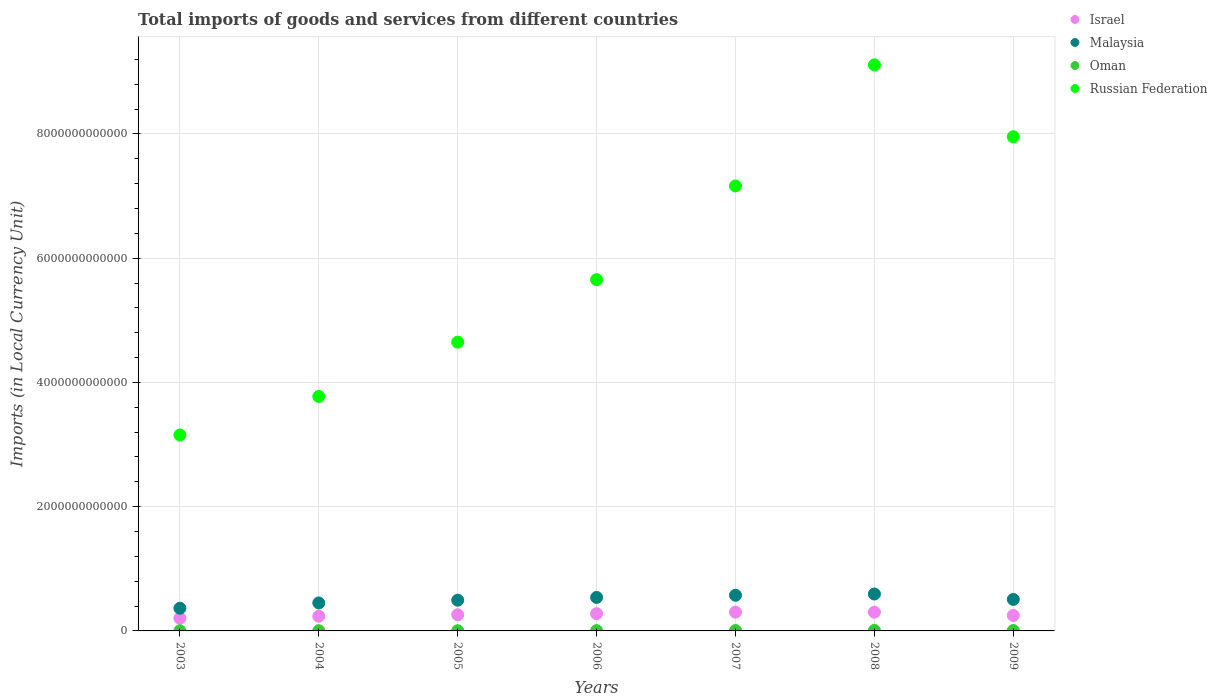How many different coloured dotlines are there?
Provide a short and direct response. 4. What is the Amount of goods and services imports in Oman in 2006?
Ensure brevity in your answer.  4.53e+09. Across all years, what is the maximum Amount of goods and services imports in Malaysia?
Offer a very short reply. 5.94e+11. Across all years, what is the minimum Amount of goods and services imports in Malaysia?
Offer a terse response. 3.65e+11. In which year was the Amount of goods and services imports in Russian Federation minimum?
Ensure brevity in your answer.  2003. What is the total Amount of goods and services imports in Russian Federation in the graph?
Your answer should be compact. 4.15e+13. What is the difference between the Amount of goods and services imports in Malaysia in 2004 and that in 2008?
Your answer should be compact. -1.44e+11. What is the difference between the Amount of goods and services imports in Malaysia in 2004 and the Amount of goods and services imports in Israel in 2007?
Your response must be concise. 1.47e+11. What is the average Amount of goods and services imports in Russian Federation per year?
Provide a succinct answer. 5.92e+12. In the year 2004, what is the difference between the Amount of goods and services imports in Malaysia and Amount of goods and services imports in Russian Federation?
Give a very brief answer. -3.32e+12. What is the ratio of the Amount of goods and services imports in Oman in 2006 to that in 2007?
Provide a short and direct response. 0.7. Is the Amount of goods and services imports in Oman in 2006 less than that in 2009?
Provide a succinct answer. Yes. Is the difference between the Amount of goods and services imports in Malaysia in 2004 and 2005 greater than the difference between the Amount of goods and services imports in Russian Federation in 2004 and 2005?
Your answer should be compact. Yes. What is the difference between the highest and the second highest Amount of goods and services imports in Oman?
Your answer should be compact. 2.24e+09. What is the difference between the highest and the lowest Amount of goods and services imports in Russian Federation?
Offer a terse response. 5.96e+12. Is the sum of the Amount of goods and services imports in Israel in 2004 and 2007 greater than the maximum Amount of goods and services imports in Russian Federation across all years?
Your answer should be very brief. No. Is the Amount of goods and services imports in Russian Federation strictly greater than the Amount of goods and services imports in Oman over the years?
Provide a short and direct response. Yes. Is the Amount of goods and services imports in Malaysia strictly less than the Amount of goods and services imports in Oman over the years?
Offer a terse response. No. How many years are there in the graph?
Your response must be concise. 7. What is the difference between two consecutive major ticks on the Y-axis?
Keep it short and to the point. 2.00e+12. Are the values on the major ticks of Y-axis written in scientific E-notation?
Your answer should be very brief. No. Does the graph contain grids?
Provide a short and direct response. Yes. How are the legend labels stacked?
Offer a terse response. Vertical. What is the title of the graph?
Make the answer very short. Total imports of goods and services from different countries. Does "Latvia" appear as one of the legend labels in the graph?
Offer a very short reply. No. What is the label or title of the X-axis?
Give a very brief answer. Years. What is the label or title of the Y-axis?
Keep it short and to the point. Imports (in Local Currency Unit). What is the Imports (in Local Currency Unit) in Israel in 2003?
Provide a succinct answer. 2.04e+11. What is the Imports (in Local Currency Unit) in Malaysia in 2003?
Offer a very short reply. 3.65e+11. What is the Imports (in Local Currency Unit) of Oman in 2003?
Provide a short and direct response. 2.73e+09. What is the Imports (in Local Currency Unit) of Russian Federation in 2003?
Give a very brief answer. 3.15e+12. What is the Imports (in Local Currency Unit) of Israel in 2004?
Offer a very short reply. 2.36e+11. What is the Imports (in Local Currency Unit) in Malaysia in 2004?
Your answer should be compact. 4.50e+11. What is the Imports (in Local Currency Unit) in Oman in 2004?
Offer a terse response. 3.70e+09. What is the Imports (in Local Currency Unit) in Russian Federation in 2004?
Provide a succinct answer. 3.77e+12. What is the Imports (in Local Currency Unit) of Israel in 2005?
Offer a very short reply. 2.61e+11. What is the Imports (in Local Currency Unit) in Malaysia in 2005?
Offer a terse response. 4.94e+11. What is the Imports (in Local Currency Unit) of Oman in 2005?
Ensure brevity in your answer.  3.71e+09. What is the Imports (in Local Currency Unit) in Russian Federation in 2005?
Keep it short and to the point. 4.65e+12. What is the Imports (in Local Currency Unit) of Israel in 2006?
Provide a short and direct response. 2.78e+11. What is the Imports (in Local Currency Unit) of Malaysia in 2006?
Your response must be concise. 5.39e+11. What is the Imports (in Local Currency Unit) of Oman in 2006?
Offer a very short reply. 4.53e+09. What is the Imports (in Local Currency Unit) in Russian Federation in 2006?
Ensure brevity in your answer.  5.65e+12. What is the Imports (in Local Currency Unit) of Israel in 2007?
Offer a very short reply. 3.03e+11. What is the Imports (in Local Currency Unit) in Malaysia in 2007?
Ensure brevity in your answer.  5.74e+11. What is the Imports (in Local Currency Unit) in Oman in 2007?
Provide a succinct answer. 6.47e+09. What is the Imports (in Local Currency Unit) in Russian Federation in 2007?
Give a very brief answer. 7.16e+12. What is the Imports (in Local Currency Unit) of Israel in 2008?
Ensure brevity in your answer.  3.02e+11. What is the Imports (in Local Currency Unit) in Malaysia in 2008?
Provide a succinct answer. 5.94e+11. What is the Imports (in Local Currency Unit) of Oman in 2008?
Offer a very short reply. 8.71e+09. What is the Imports (in Local Currency Unit) of Russian Federation in 2008?
Your response must be concise. 9.11e+12. What is the Imports (in Local Currency Unit) in Israel in 2009?
Give a very brief answer. 2.49e+11. What is the Imports (in Local Currency Unit) of Malaysia in 2009?
Offer a very short reply. 5.07e+11. What is the Imports (in Local Currency Unit) of Oman in 2009?
Provide a succinct answer. 6.45e+09. What is the Imports (in Local Currency Unit) of Russian Federation in 2009?
Your answer should be very brief. 7.95e+12. Across all years, what is the maximum Imports (in Local Currency Unit) in Israel?
Offer a terse response. 3.03e+11. Across all years, what is the maximum Imports (in Local Currency Unit) in Malaysia?
Ensure brevity in your answer.  5.94e+11. Across all years, what is the maximum Imports (in Local Currency Unit) in Oman?
Ensure brevity in your answer.  8.71e+09. Across all years, what is the maximum Imports (in Local Currency Unit) in Russian Federation?
Make the answer very short. 9.11e+12. Across all years, what is the minimum Imports (in Local Currency Unit) of Israel?
Offer a terse response. 2.04e+11. Across all years, what is the minimum Imports (in Local Currency Unit) of Malaysia?
Keep it short and to the point. 3.65e+11. Across all years, what is the minimum Imports (in Local Currency Unit) of Oman?
Make the answer very short. 2.73e+09. Across all years, what is the minimum Imports (in Local Currency Unit) of Russian Federation?
Your response must be concise. 3.15e+12. What is the total Imports (in Local Currency Unit) of Israel in the graph?
Ensure brevity in your answer.  1.83e+12. What is the total Imports (in Local Currency Unit) in Malaysia in the graph?
Ensure brevity in your answer.  3.53e+12. What is the total Imports (in Local Currency Unit) of Oman in the graph?
Ensure brevity in your answer.  3.63e+1. What is the total Imports (in Local Currency Unit) of Russian Federation in the graph?
Provide a short and direct response. 4.15e+13. What is the difference between the Imports (in Local Currency Unit) of Israel in 2003 and that in 2004?
Ensure brevity in your answer.  -3.24e+1. What is the difference between the Imports (in Local Currency Unit) of Malaysia in 2003 and that in 2004?
Your answer should be very brief. -8.50e+1. What is the difference between the Imports (in Local Currency Unit) of Oman in 2003 and that in 2004?
Offer a terse response. -9.73e+08. What is the difference between the Imports (in Local Currency Unit) of Russian Federation in 2003 and that in 2004?
Ensure brevity in your answer.  -6.20e+11. What is the difference between the Imports (in Local Currency Unit) in Israel in 2003 and that in 2005?
Give a very brief answer. -5.69e+1. What is the difference between the Imports (in Local Currency Unit) of Malaysia in 2003 and that in 2005?
Offer a very short reply. -1.29e+11. What is the difference between the Imports (in Local Currency Unit) in Oman in 2003 and that in 2005?
Your answer should be very brief. -9.84e+08. What is the difference between the Imports (in Local Currency Unit) in Russian Federation in 2003 and that in 2005?
Your answer should be compact. -1.49e+12. What is the difference between the Imports (in Local Currency Unit) of Israel in 2003 and that in 2006?
Give a very brief answer. -7.39e+1. What is the difference between the Imports (in Local Currency Unit) in Malaysia in 2003 and that in 2006?
Keep it short and to the point. -1.74e+11. What is the difference between the Imports (in Local Currency Unit) in Oman in 2003 and that in 2006?
Give a very brief answer. -1.80e+09. What is the difference between the Imports (in Local Currency Unit) of Russian Federation in 2003 and that in 2006?
Ensure brevity in your answer.  -2.50e+12. What is the difference between the Imports (in Local Currency Unit) of Israel in 2003 and that in 2007?
Provide a succinct answer. -9.89e+1. What is the difference between the Imports (in Local Currency Unit) in Malaysia in 2003 and that in 2007?
Ensure brevity in your answer.  -2.09e+11. What is the difference between the Imports (in Local Currency Unit) in Oman in 2003 and that in 2007?
Make the answer very short. -3.74e+09. What is the difference between the Imports (in Local Currency Unit) of Russian Federation in 2003 and that in 2007?
Your response must be concise. -4.01e+12. What is the difference between the Imports (in Local Currency Unit) of Israel in 2003 and that in 2008?
Your answer should be compact. -9.79e+1. What is the difference between the Imports (in Local Currency Unit) in Malaysia in 2003 and that in 2008?
Offer a terse response. -2.29e+11. What is the difference between the Imports (in Local Currency Unit) in Oman in 2003 and that in 2008?
Ensure brevity in your answer.  -5.98e+09. What is the difference between the Imports (in Local Currency Unit) in Russian Federation in 2003 and that in 2008?
Offer a terse response. -5.96e+12. What is the difference between the Imports (in Local Currency Unit) of Israel in 2003 and that in 2009?
Give a very brief answer. -4.50e+1. What is the difference between the Imports (in Local Currency Unit) in Malaysia in 2003 and that in 2009?
Provide a succinct answer. -1.42e+11. What is the difference between the Imports (in Local Currency Unit) in Oman in 2003 and that in 2009?
Make the answer very short. -3.72e+09. What is the difference between the Imports (in Local Currency Unit) of Russian Federation in 2003 and that in 2009?
Provide a short and direct response. -4.80e+12. What is the difference between the Imports (in Local Currency Unit) in Israel in 2004 and that in 2005?
Give a very brief answer. -2.45e+1. What is the difference between the Imports (in Local Currency Unit) of Malaysia in 2004 and that in 2005?
Provide a short and direct response. -4.41e+1. What is the difference between the Imports (in Local Currency Unit) of Oman in 2004 and that in 2005?
Your answer should be very brief. -1.10e+07. What is the difference between the Imports (in Local Currency Unit) of Russian Federation in 2004 and that in 2005?
Make the answer very short. -8.74e+11. What is the difference between the Imports (in Local Currency Unit) of Israel in 2004 and that in 2006?
Ensure brevity in your answer.  -4.15e+1. What is the difference between the Imports (in Local Currency Unit) of Malaysia in 2004 and that in 2006?
Give a very brief answer. -8.91e+1. What is the difference between the Imports (in Local Currency Unit) of Oman in 2004 and that in 2006?
Provide a short and direct response. -8.30e+08. What is the difference between the Imports (in Local Currency Unit) in Russian Federation in 2004 and that in 2006?
Provide a succinct answer. -1.88e+12. What is the difference between the Imports (in Local Currency Unit) in Israel in 2004 and that in 2007?
Keep it short and to the point. -6.65e+1. What is the difference between the Imports (in Local Currency Unit) in Malaysia in 2004 and that in 2007?
Offer a very short reply. -1.24e+11. What is the difference between the Imports (in Local Currency Unit) of Oman in 2004 and that in 2007?
Keep it short and to the point. -2.77e+09. What is the difference between the Imports (in Local Currency Unit) of Russian Federation in 2004 and that in 2007?
Give a very brief answer. -3.39e+12. What is the difference between the Imports (in Local Currency Unit) in Israel in 2004 and that in 2008?
Ensure brevity in your answer.  -6.55e+1. What is the difference between the Imports (in Local Currency Unit) of Malaysia in 2004 and that in 2008?
Keep it short and to the point. -1.44e+11. What is the difference between the Imports (in Local Currency Unit) in Oman in 2004 and that in 2008?
Provide a short and direct response. -5.01e+09. What is the difference between the Imports (in Local Currency Unit) in Russian Federation in 2004 and that in 2008?
Provide a succinct answer. -5.34e+12. What is the difference between the Imports (in Local Currency Unit) in Israel in 2004 and that in 2009?
Your response must be concise. -1.26e+1. What is the difference between the Imports (in Local Currency Unit) of Malaysia in 2004 and that in 2009?
Ensure brevity in your answer.  -5.68e+1. What is the difference between the Imports (in Local Currency Unit) in Oman in 2004 and that in 2009?
Your response must be concise. -2.74e+09. What is the difference between the Imports (in Local Currency Unit) of Russian Federation in 2004 and that in 2009?
Keep it short and to the point. -4.18e+12. What is the difference between the Imports (in Local Currency Unit) in Israel in 2005 and that in 2006?
Your answer should be compact. -1.70e+1. What is the difference between the Imports (in Local Currency Unit) in Malaysia in 2005 and that in 2006?
Make the answer very short. -4.50e+1. What is the difference between the Imports (in Local Currency Unit) in Oman in 2005 and that in 2006?
Make the answer very short. -8.19e+08. What is the difference between the Imports (in Local Currency Unit) of Russian Federation in 2005 and that in 2006?
Provide a short and direct response. -1.01e+12. What is the difference between the Imports (in Local Currency Unit) in Israel in 2005 and that in 2007?
Give a very brief answer. -4.20e+1. What is the difference between the Imports (in Local Currency Unit) of Malaysia in 2005 and that in 2007?
Your answer should be compact. -7.98e+1. What is the difference between the Imports (in Local Currency Unit) of Oman in 2005 and that in 2007?
Ensure brevity in your answer.  -2.76e+09. What is the difference between the Imports (in Local Currency Unit) of Russian Federation in 2005 and that in 2007?
Keep it short and to the point. -2.51e+12. What is the difference between the Imports (in Local Currency Unit) of Israel in 2005 and that in 2008?
Ensure brevity in your answer.  -4.10e+1. What is the difference between the Imports (in Local Currency Unit) in Malaysia in 2005 and that in 2008?
Provide a short and direct response. -9.97e+1. What is the difference between the Imports (in Local Currency Unit) in Oman in 2005 and that in 2008?
Your answer should be compact. -5.00e+09. What is the difference between the Imports (in Local Currency Unit) of Russian Federation in 2005 and that in 2008?
Offer a terse response. -4.46e+12. What is the difference between the Imports (in Local Currency Unit) of Israel in 2005 and that in 2009?
Your answer should be very brief. 1.18e+1. What is the difference between the Imports (in Local Currency Unit) in Malaysia in 2005 and that in 2009?
Provide a short and direct response. -1.27e+1. What is the difference between the Imports (in Local Currency Unit) in Oman in 2005 and that in 2009?
Ensure brevity in your answer.  -2.73e+09. What is the difference between the Imports (in Local Currency Unit) of Russian Federation in 2005 and that in 2009?
Your response must be concise. -3.31e+12. What is the difference between the Imports (in Local Currency Unit) in Israel in 2006 and that in 2007?
Ensure brevity in your answer.  -2.50e+1. What is the difference between the Imports (in Local Currency Unit) in Malaysia in 2006 and that in 2007?
Offer a terse response. -3.47e+1. What is the difference between the Imports (in Local Currency Unit) in Oman in 2006 and that in 2007?
Your response must be concise. -1.94e+09. What is the difference between the Imports (in Local Currency Unit) of Russian Federation in 2006 and that in 2007?
Make the answer very short. -1.51e+12. What is the difference between the Imports (in Local Currency Unit) of Israel in 2006 and that in 2008?
Provide a succinct answer. -2.40e+1. What is the difference between the Imports (in Local Currency Unit) in Malaysia in 2006 and that in 2008?
Your answer should be compact. -5.47e+1. What is the difference between the Imports (in Local Currency Unit) in Oman in 2006 and that in 2008?
Offer a terse response. -4.18e+09. What is the difference between the Imports (in Local Currency Unit) in Russian Federation in 2006 and that in 2008?
Provide a short and direct response. -3.46e+12. What is the difference between the Imports (in Local Currency Unit) in Israel in 2006 and that in 2009?
Keep it short and to the point. 2.88e+1. What is the difference between the Imports (in Local Currency Unit) of Malaysia in 2006 and that in 2009?
Provide a succinct answer. 3.23e+1. What is the difference between the Imports (in Local Currency Unit) in Oman in 2006 and that in 2009?
Your answer should be very brief. -1.92e+09. What is the difference between the Imports (in Local Currency Unit) in Russian Federation in 2006 and that in 2009?
Your answer should be compact. -2.30e+12. What is the difference between the Imports (in Local Currency Unit) in Israel in 2007 and that in 2008?
Offer a very short reply. 1.01e+09. What is the difference between the Imports (in Local Currency Unit) of Malaysia in 2007 and that in 2008?
Provide a short and direct response. -2.00e+1. What is the difference between the Imports (in Local Currency Unit) in Oman in 2007 and that in 2008?
Your answer should be very brief. -2.24e+09. What is the difference between the Imports (in Local Currency Unit) of Russian Federation in 2007 and that in 2008?
Offer a very short reply. -1.95e+12. What is the difference between the Imports (in Local Currency Unit) in Israel in 2007 and that in 2009?
Provide a short and direct response. 5.39e+1. What is the difference between the Imports (in Local Currency Unit) of Malaysia in 2007 and that in 2009?
Your response must be concise. 6.70e+1. What is the difference between the Imports (in Local Currency Unit) in Oman in 2007 and that in 2009?
Offer a very short reply. 2.50e+07. What is the difference between the Imports (in Local Currency Unit) in Russian Federation in 2007 and that in 2009?
Your answer should be compact. -7.92e+11. What is the difference between the Imports (in Local Currency Unit) in Israel in 2008 and that in 2009?
Provide a succinct answer. 5.28e+1. What is the difference between the Imports (in Local Currency Unit) in Malaysia in 2008 and that in 2009?
Make the answer very short. 8.70e+1. What is the difference between the Imports (in Local Currency Unit) of Oman in 2008 and that in 2009?
Your response must be concise. 2.26e+09. What is the difference between the Imports (in Local Currency Unit) in Russian Federation in 2008 and that in 2009?
Provide a short and direct response. 1.16e+12. What is the difference between the Imports (in Local Currency Unit) in Israel in 2003 and the Imports (in Local Currency Unit) in Malaysia in 2004?
Give a very brief answer. -2.46e+11. What is the difference between the Imports (in Local Currency Unit) of Israel in 2003 and the Imports (in Local Currency Unit) of Oman in 2004?
Your response must be concise. 2.00e+11. What is the difference between the Imports (in Local Currency Unit) of Israel in 2003 and the Imports (in Local Currency Unit) of Russian Federation in 2004?
Your answer should be compact. -3.57e+12. What is the difference between the Imports (in Local Currency Unit) in Malaysia in 2003 and the Imports (in Local Currency Unit) in Oman in 2004?
Provide a short and direct response. 3.62e+11. What is the difference between the Imports (in Local Currency Unit) in Malaysia in 2003 and the Imports (in Local Currency Unit) in Russian Federation in 2004?
Keep it short and to the point. -3.41e+12. What is the difference between the Imports (in Local Currency Unit) in Oman in 2003 and the Imports (in Local Currency Unit) in Russian Federation in 2004?
Make the answer very short. -3.77e+12. What is the difference between the Imports (in Local Currency Unit) in Israel in 2003 and the Imports (in Local Currency Unit) in Malaysia in 2005?
Offer a terse response. -2.90e+11. What is the difference between the Imports (in Local Currency Unit) in Israel in 2003 and the Imports (in Local Currency Unit) in Oman in 2005?
Provide a short and direct response. 2.00e+11. What is the difference between the Imports (in Local Currency Unit) of Israel in 2003 and the Imports (in Local Currency Unit) of Russian Federation in 2005?
Offer a very short reply. -4.44e+12. What is the difference between the Imports (in Local Currency Unit) of Malaysia in 2003 and the Imports (in Local Currency Unit) of Oman in 2005?
Make the answer very short. 3.62e+11. What is the difference between the Imports (in Local Currency Unit) of Malaysia in 2003 and the Imports (in Local Currency Unit) of Russian Federation in 2005?
Your answer should be very brief. -4.28e+12. What is the difference between the Imports (in Local Currency Unit) of Oman in 2003 and the Imports (in Local Currency Unit) of Russian Federation in 2005?
Ensure brevity in your answer.  -4.65e+12. What is the difference between the Imports (in Local Currency Unit) of Israel in 2003 and the Imports (in Local Currency Unit) of Malaysia in 2006?
Provide a short and direct response. -3.35e+11. What is the difference between the Imports (in Local Currency Unit) in Israel in 2003 and the Imports (in Local Currency Unit) in Oman in 2006?
Your answer should be compact. 2.00e+11. What is the difference between the Imports (in Local Currency Unit) of Israel in 2003 and the Imports (in Local Currency Unit) of Russian Federation in 2006?
Keep it short and to the point. -5.45e+12. What is the difference between the Imports (in Local Currency Unit) of Malaysia in 2003 and the Imports (in Local Currency Unit) of Oman in 2006?
Keep it short and to the point. 3.61e+11. What is the difference between the Imports (in Local Currency Unit) of Malaysia in 2003 and the Imports (in Local Currency Unit) of Russian Federation in 2006?
Provide a succinct answer. -5.29e+12. What is the difference between the Imports (in Local Currency Unit) of Oman in 2003 and the Imports (in Local Currency Unit) of Russian Federation in 2006?
Give a very brief answer. -5.65e+12. What is the difference between the Imports (in Local Currency Unit) in Israel in 2003 and the Imports (in Local Currency Unit) in Malaysia in 2007?
Your response must be concise. -3.70e+11. What is the difference between the Imports (in Local Currency Unit) of Israel in 2003 and the Imports (in Local Currency Unit) of Oman in 2007?
Provide a succinct answer. 1.98e+11. What is the difference between the Imports (in Local Currency Unit) in Israel in 2003 and the Imports (in Local Currency Unit) in Russian Federation in 2007?
Ensure brevity in your answer.  -6.96e+12. What is the difference between the Imports (in Local Currency Unit) of Malaysia in 2003 and the Imports (in Local Currency Unit) of Oman in 2007?
Provide a succinct answer. 3.59e+11. What is the difference between the Imports (in Local Currency Unit) of Malaysia in 2003 and the Imports (in Local Currency Unit) of Russian Federation in 2007?
Your answer should be compact. -6.80e+12. What is the difference between the Imports (in Local Currency Unit) in Oman in 2003 and the Imports (in Local Currency Unit) in Russian Federation in 2007?
Keep it short and to the point. -7.16e+12. What is the difference between the Imports (in Local Currency Unit) in Israel in 2003 and the Imports (in Local Currency Unit) in Malaysia in 2008?
Your response must be concise. -3.90e+11. What is the difference between the Imports (in Local Currency Unit) in Israel in 2003 and the Imports (in Local Currency Unit) in Oman in 2008?
Your answer should be very brief. 1.95e+11. What is the difference between the Imports (in Local Currency Unit) in Israel in 2003 and the Imports (in Local Currency Unit) in Russian Federation in 2008?
Ensure brevity in your answer.  -8.91e+12. What is the difference between the Imports (in Local Currency Unit) of Malaysia in 2003 and the Imports (in Local Currency Unit) of Oman in 2008?
Keep it short and to the point. 3.57e+11. What is the difference between the Imports (in Local Currency Unit) in Malaysia in 2003 and the Imports (in Local Currency Unit) in Russian Federation in 2008?
Your answer should be compact. -8.75e+12. What is the difference between the Imports (in Local Currency Unit) of Oman in 2003 and the Imports (in Local Currency Unit) of Russian Federation in 2008?
Your response must be concise. -9.11e+12. What is the difference between the Imports (in Local Currency Unit) in Israel in 2003 and the Imports (in Local Currency Unit) in Malaysia in 2009?
Make the answer very short. -3.03e+11. What is the difference between the Imports (in Local Currency Unit) in Israel in 2003 and the Imports (in Local Currency Unit) in Oman in 2009?
Offer a terse response. 1.98e+11. What is the difference between the Imports (in Local Currency Unit) in Israel in 2003 and the Imports (in Local Currency Unit) in Russian Federation in 2009?
Keep it short and to the point. -7.75e+12. What is the difference between the Imports (in Local Currency Unit) of Malaysia in 2003 and the Imports (in Local Currency Unit) of Oman in 2009?
Your answer should be very brief. 3.59e+11. What is the difference between the Imports (in Local Currency Unit) in Malaysia in 2003 and the Imports (in Local Currency Unit) in Russian Federation in 2009?
Provide a short and direct response. -7.59e+12. What is the difference between the Imports (in Local Currency Unit) in Oman in 2003 and the Imports (in Local Currency Unit) in Russian Federation in 2009?
Offer a very short reply. -7.95e+12. What is the difference between the Imports (in Local Currency Unit) in Israel in 2004 and the Imports (in Local Currency Unit) in Malaysia in 2005?
Your answer should be compact. -2.58e+11. What is the difference between the Imports (in Local Currency Unit) of Israel in 2004 and the Imports (in Local Currency Unit) of Oman in 2005?
Your answer should be very brief. 2.33e+11. What is the difference between the Imports (in Local Currency Unit) of Israel in 2004 and the Imports (in Local Currency Unit) of Russian Federation in 2005?
Your answer should be very brief. -4.41e+12. What is the difference between the Imports (in Local Currency Unit) of Malaysia in 2004 and the Imports (in Local Currency Unit) of Oman in 2005?
Offer a terse response. 4.47e+11. What is the difference between the Imports (in Local Currency Unit) in Malaysia in 2004 and the Imports (in Local Currency Unit) in Russian Federation in 2005?
Your response must be concise. -4.20e+12. What is the difference between the Imports (in Local Currency Unit) in Oman in 2004 and the Imports (in Local Currency Unit) in Russian Federation in 2005?
Your answer should be very brief. -4.64e+12. What is the difference between the Imports (in Local Currency Unit) in Israel in 2004 and the Imports (in Local Currency Unit) in Malaysia in 2006?
Offer a terse response. -3.03e+11. What is the difference between the Imports (in Local Currency Unit) in Israel in 2004 and the Imports (in Local Currency Unit) in Oman in 2006?
Offer a terse response. 2.32e+11. What is the difference between the Imports (in Local Currency Unit) in Israel in 2004 and the Imports (in Local Currency Unit) in Russian Federation in 2006?
Give a very brief answer. -5.42e+12. What is the difference between the Imports (in Local Currency Unit) of Malaysia in 2004 and the Imports (in Local Currency Unit) of Oman in 2006?
Keep it short and to the point. 4.46e+11. What is the difference between the Imports (in Local Currency Unit) of Malaysia in 2004 and the Imports (in Local Currency Unit) of Russian Federation in 2006?
Provide a short and direct response. -5.20e+12. What is the difference between the Imports (in Local Currency Unit) in Oman in 2004 and the Imports (in Local Currency Unit) in Russian Federation in 2006?
Make the answer very short. -5.65e+12. What is the difference between the Imports (in Local Currency Unit) in Israel in 2004 and the Imports (in Local Currency Unit) in Malaysia in 2007?
Your answer should be very brief. -3.38e+11. What is the difference between the Imports (in Local Currency Unit) in Israel in 2004 and the Imports (in Local Currency Unit) in Oman in 2007?
Offer a terse response. 2.30e+11. What is the difference between the Imports (in Local Currency Unit) in Israel in 2004 and the Imports (in Local Currency Unit) in Russian Federation in 2007?
Provide a short and direct response. -6.93e+12. What is the difference between the Imports (in Local Currency Unit) in Malaysia in 2004 and the Imports (in Local Currency Unit) in Oman in 2007?
Your answer should be very brief. 4.44e+11. What is the difference between the Imports (in Local Currency Unit) of Malaysia in 2004 and the Imports (in Local Currency Unit) of Russian Federation in 2007?
Your response must be concise. -6.71e+12. What is the difference between the Imports (in Local Currency Unit) in Oman in 2004 and the Imports (in Local Currency Unit) in Russian Federation in 2007?
Your answer should be very brief. -7.16e+12. What is the difference between the Imports (in Local Currency Unit) of Israel in 2004 and the Imports (in Local Currency Unit) of Malaysia in 2008?
Your answer should be very brief. -3.58e+11. What is the difference between the Imports (in Local Currency Unit) of Israel in 2004 and the Imports (in Local Currency Unit) of Oman in 2008?
Make the answer very short. 2.28e+11. What is the difference between the Imports (in Local Currency Unit) in Israel in 2004 and the Imports (in Local Currency Unit) in Russian Federation in 2008?
Provide a short and direct response. -8.87e+12. What is the difference between the Imports (in Local Currency Unit) of Malaysia in 2004 and the Imports (in Local Currency Unit) of Oman in 2008?
Offer a terse response. 4.42e+11. What is the difference between the Imports (in Local Currency Unit) in Malaysia in 2004 and the Imports (in Local Currency Unit) in Russian Federation in 2008?
Offer a terse response. -8.66e+12. What is the difference between the Imports (in Local Currency Unit) of Oman in 2004 and the Imports (in Local Currency Unit) of Russian Federation in 2008?
Make the answer very short. -9.11e+12. What is the difference between the Imports (in Local Currency Unit) in Israel in 2004 and the Imports (in Local Currency Unit) in Malaysia in 2009?
Your response must be concise. -2.71e+11. What is the difference between the Imports (in Local Currency Unit) of Israel in 2004 and the Imports (in Local Currency Unit) of Oman in 2009?
Give a very brief answer. 2.30e+11. What is the difference between the Imports (in Local Currency Unit) of Israel in 2004 and the Imports (in Local Currency Unit) of Russian Federation in 2009?
Your response must be concise. -7.72e+12. What is the difference between the Imports (in Local Currency Unit) in Malaysia in 2004 and the Imports (in Local Currency Unit) in Oman in 2009?
Provide a succinct answer. 4.44e+11. What is the difference between the Imports (in Local Currency Unit) in Malaysia in 2004 and the Imports (in Local Currency Unit) in Russian Federation in 2009?
Provide a succinct answer. -7.50e+12. What is the difference between the Imports (in Local Currency Unit) in Oman in 2004 and the Imports (in Local Currency Unit) in Russian Federation in 2009?
Give a very brief answer. -7.95e+12. What is the difference between the Imports (in Local Currency Unit) of Israel in 2005 and the Imports (in Local Currency Unit) of Malaysia in 2006?
Keep it short and to the point. -2.79e+11. What is the difference between the Imports (in Local Currency Unit) of Israel in 2005 and the Imports (in Local Currency Unit) of Oman in 2006?
Give a very brief answer. 2.56e+11. What is the difference between the Imports (in Local Currency Unit) in Israel in 2005 and the Imports (in Local Currency Unit) in Russian Federation in 2006?
Give a very brief answer. -5.39e+12. What is the difference between the Imports (in Local Currency Unit) of Malaysia in 2005 and the Imports (in Local Currency Unit) of Oman in 2006?
Provide a succinct answer. 4.90e+11. What is the difference between the Imports (in Local Currency Unit) of Malaysia in 2005 and the Imports (in Local Currency Unit) of Russian Federation in 2006?
Give a very brief answer. -5.16e+12. What is the difference between the Imports (in Local Currency Unit) in Oman in 2005 and the Imports (in Local Currency Unit) in Russian Federation in 2006?
Provide a succinct answer. -5.65e+12. What is the difference between the Imports (in Local Currency Unit) of Israel in 2005 and the Imports (in Local Currency Unit) of Malaysia in 2007?
Make the answer very short. -3.13e+11. What is the difference between the Imports (in Local Currency Unit) of Israel in 2005 and the Imports (in Local Currency Unit) of Oman in 2007?
Your answer should be compact. 2.54e+11. What is the difference between the Imports (in Local Currency Unit) in Israel in 2005 and the Imports (in Local Currency Unit) in Russian Federation in 2007?
Your answer should be very brief. -6.90e+12. What is the difference between the Imports (in Local Currency Unit) in Malaysia in 2005 and the Imports (in Local Currency Unit) in Oman in 2007?
Provide a succinct answer. 4.88e+11. What is the difference between the Imports (in Local Currency Unit) of Malaysia in 2005 and the Imports (in Local Currency Unit) of Russian Federation in 2007?
Your answer should be compact. -6.67e+12. What is the difference between the Imports (in Local Currency Unit) in Oman in 2005 and the Imports (in Local Currency Unit) in Russian Federation in 2007?
Your answer should be very brief. -7.16e+12. What is the difference between the Imports (in Local Currency Unit) of Israel in 2005 and the Imports (in Local Currency Unit) of Malaysia in 2008?
Ensure brevity in your answer.  -3.33e+11. What is the difference between the Imports (in Local Currency Unit) in Israel in 2005 and the Imports (in Local Currency Unit) in Oman in 2008?
Provide a succinct answer. 2.52e+11. What is the difference between the Imports (in Local Currency Unit) in Israel in 2005 and the Imports (in Local Currency Unit) in Russian Federation in 2008?
Give a very brief answer. -8.85e+12. What is the difference between the Imports (in Local Currency Unit) of Malaysia in 2005 and the Imports (in Local Currency Unit) of Oman in 2008?
Offer a terse response. 4.86e+11. What is the difference between the Imports (in Local Currency Unit) in Malaysia in 2005 and the Imports (in Local Currency Unit) in Russian Federation in 2008?
Provide a succinct answer. -8.62e+12. What is the difference between the Imports (in Local Currency Unit) in Oman in 2005 and the Imports (in Local Currency Unit) in Russian Federation in 2008?
Ensure brevity in your answer.  -9.11e+12. What is the difference between the Imports (in Local Currency Unit) of Israel in 2005 and the Imports (in Local Currency Unit) of Malaysia in 2009?
Offer a terse response. -2.46e+11. What is the difference between the Imports (in Local Currency Unit) in Israel in 2005 and the Imports (in Local Currency Unit) in Oman in 2009?
Provide a short and direct response. 2.54e+11. What is the difference between the Imports (in Local Currency Unit) of Israel in 2005 and the Imports (in Local Currency Unit) of Russian Federation in 2009?
Offer a terse response. -7.69e+12. What is the difference between the Imports (in Local Currency Unit) of Malaysia in 2005 and the Imports (in Local Currency Unit) of Oman in 2009?
Offer a terse response. 4.88e+11. What is the difference between the Imports (in Local Currency Unit) in Malaysia in 2005 and the Imports (in Local Currency Unit) in Russian Federation in 2009?
Offer a very short reply. -7.46e+12. What is the difference between the Imports (in Local Currency Unit) of Oman in 2005 and the Imports (in Local Currency Unit) of Russian Federation in 2009?
Your response must be concise. -7.95e+12. What is the difference between the Imports (in Local Currency Unit) in Israel in 2006 and the Imports (in Local Currency Unit) in Malaysia in 2007?
Ensure brevity in your answer.  -2.96e+11. What is the difference between the Imports (in Local Currency Unit) in Israel in 2006 and the Imports (in Local Currency Unit) in Oman in 2007?
Give a very brief answer. 2.71e+11. What is the difference between the Imports (in Local Currency Unit) of Israel in 2006 and the Imports (in Local Currency Unit) of Russian Federation in 2007?
Provide a short and direct response. -6.88e+12. What is the difference between the Imports (in Local Currency Unit) in Malaysia in 2006 and the Imports (in Local Currency Unit) in Oman in 2007?
Keep it short and to the point. 5.33e+11. What is the difference between the Imports (in Local Currency Unit) in Malaysia in 2006 and the Imports (in Local Currency Unit) in Russian Federation in 2007?
Give a very brief answer. -6.62e+12. What is the difference between the Imports (in Local Currency Unit) in Oman in 2006 and the Imports (in Local Currency Unit) in Russian Federation in 2007?
Keep it short and to the point. -7.16e+12. What is the difference between the Imports (in Local Currency Unit) of Israel in 2006 and the Imports (in Local Currency Unit) of Malaysia in 2008?
Provide a short and direct response. -3.16e+11. What is the difference between the Imports (in Local Currency Unit) of Israel in 2006 and the Imports (in Local Currency Unit) of Oman in 2008?
Offer a terse response. 2.69e+11. What is the difference between the Imports (in Local Currency Unit) of Israel in 2006 and the Imports (in Local Currency Unit) of Russian Federation in 2008?
Your answer should be very brief. -8.83e+12. What is the difference between the Imports (in Local Currency Unit) in Malaysia in 2006 and the Imports (in Local Currency Unit) in Oman in 2008?
Your response must be concise. 5.31e+11. What is the difference between the Imports (in Local Currency Unit) in Malaysia in 2006 and the Imports (in Local Currency Unit) in Russian Federation in 2008?
Ensure brevity in your answer.  -8.57e+12. What is the difference between the Imports (in Local Currency Unit) of Oman in 2006 and the Imports (in Local Currency Unit) of Russian Federation in 2008?
Your answer should be very brief. -9.11e+12. What is the difference between the Imports (in Local Currency Unit) in Israel in 2006 and the Imports (in Local Currency Unit) in Malaysia in 2009?
Provide a short and direct response. -2.29e+11. What is the difference between the Imports (in Local Currency Unit) in Israel in 2006 and the Imports (in Local Currency Unit) in Oman in 2009?
Your answer should be compact. 2.71e+11. What is the difference between the Imports (in Local Currency Unit) in Israel in 2006 and the Imports (in Local Currency Unit) in Russian Federation in 2009?
Make the answer very short. -7.68e+12. What is the difference between the Imports (in Local Currency Unit) of Malaysia in 2006 and the Imports (in Local Currency Unit) of Oman in 2009?
Offer a terse response. 5.33e+11. What is the difference between the Imports (in Local Currency Unit) of Malaysia in 2006 and the Imports (in Local Currency Unit) of Russian Federation in 2009?
Offer a very short reply. -7.41e+12. What is the difference between the Imports (in Local Currency Unit) of Oman in 2006 and the Imports (in Local Currency Unit) of Russian Federation in 2009?
Offer a very short reply. -7.95e+12. What is the difference between the Imports (in Local Currency Unit) in Israel in 2007 and the Imports (in Local Currency Unit) in Malaysia in 2008?
Your answer should be very brief. -2.91e+11. What is the difference between the Imports (in Local Currency Unit) in Israel in 2007 and the Imports (in Local Currency Unit) in Oman in 2008?
Provide a short and direct response. 2.94e+11. What is the difference between the Imports (in Local Currency Unit) in Israel in 2007 and the Imports (in Local Currency Unit) in Russian Federation in 2008?
Ensure brevity in your answer.  -8.81e+12. What is the difference between the Imports (in Local Currency Unit) in Malaysia in 2007 and the Imports (in Local Currency Unit) in Oman in 2008?
Provide a succinct answer. 5.65e+11. What is the difference between the Imports (in Local Currency Unit) of Malaysia in 2007 and the Imports (in Local Currency Unit) of Russian Federation in 2008?
Make the answer very short. -8.54e+12. What is the difference between the Imports (in Local Currency Unit) in Oman in 2007 and the Imports (in Local Currency Unit) in Russian Federation in 2008?
Your answer should be compact. -9.10e+12. What is the difference between the Imports (in Local Currency Unit) in Israel in 2007 and the Imports (in Local Currency Unit) in Malaysia in 2009?
Offer a terse response. -2.04e+11. What is the difference between the Imports (in Local Currency Unit) in Israel in 2007 and the Imports (in Local Currency Unit) in Oman in 2009?
Keep it short and to the point. 2.97e+11. What is the difference between the Imports (in Local Currency Unit) in Israel in 2007 and the Imports (in Local Currency Unit) in Russian Federation in 2009?
Offer a very short reply. -7.65e+12. What is the difference between the Imports (in Local Currency Unit) of Malaysia in 2007 and the Imports (in Local Currency Unit) of Oman in 2009?
Your answer should be very brief. 5.68e+11. What is the difference between the Imports (in Local Currency Unit) of Malaysia in 2007 and the Imports (in Local Currency Unit) of Russian Federation in 2009?
Offer a very short reply. -7.38e+12. What is the difference between the Imports (in Local Currency Unit) of Oman in 2007 and the Imports (in Local Currency Unit) of Russian Federation in 2009?
Ensure brevity in your answer.  -7.95e+12. What is the difference between the Imports (in Local Currency Unit) in Israel in 2008 and the Imports (in Local Currency Unit) in Malaysia in 2009?
Keep it short and to the point. -2.05e+11. What is the difference between the Imports (in Local Currency Unit) of Israel in 2008 and the Imports (in Local Currency Unit) of Oman in 2009?
Keep it short and to the point. 2.96e+11. What is the difference between the Imports (in Local Currency Unit) of Israel in 2008 and the Imports (in Local Currency Unit) of Russian Federation in 2009?
Offer a terse response. -7.65e+12. What is the difference between the Imports (in Local Currency Unit) in Malaysia in 2008 and the Imports (in Local Currency Unit) in Oman in 2009?
Offer a very short reply. 5.88e+11. What is the difference between the Imports (in Local Currency Unit) of Malaysia in 2008 and the Imports (in Local Currency Unit) of Russian Federation in 2009?
Ensure brevity in your answer.  -7.36e+12. What is the difference between the Imports (in Local Currency Unit) of Oman in 2008 and the Imports (in Local Currency Unit) of Russian Federation in 2009?
Offer a terse response. -7.95e+12. What is the average Imports (in Local Currency Unit) in Israel per year?
Give a very brief answer. 2.62e+11. What is the average Imports (in Local Currency Unit) in Malaysia per year?
Keep it short and to the point. 5.04e+11. What is the average Imports (in Local Currency Unit) of Oman per year?
Your answer should be compact. 5.19e+09. What is the average Imports (in Local Currency Unit) of Russian Federation per year?
Your answer should be very brief. 5.92e+12. In the year 2003, what is the difference between the Imports (in Local Currency Unit) in Israel and Imports (in Local Currency Unit) in Malaysia?
Offer a terse response. -1.61e+11. In the year 2003, what is the difference between the Imports (in Local Currency Unit) in Israel and Imports (in Local Currency Unit) in Oman?
Offer a terse response. 2.01e+11. In the year 2003, what is the difference between the Imports (in Local Currency Unit) in Israel and Imports (in Local Currency Unit) in Russian Federation?
Offer a very short reply. -2.95e+12. In the year 2003, what is the difference between the Imports (in Local Currency Unit) of Malaysia and Imports (in Local Currency Unit) of Oman?
Your response must be concise. 3.63e+11. In the year 2003, what is the difference between the Imports (in Local Currency Unit) in Malaysia and Imports (in Local Currency Unit) in Russian Federation?
Provide a short and direct response. -2.79e+12. In the year 2003, what is the difference between the Imports (in Local Currency Unit) in Oman and Imports (in Local Currency Unit) in Russian Federation?
Offer a terse response. -3.15e+12. In the year 2004, what is the difference between the Imports (in Local Currency Unit) in Israel and Imports (in Local Currency Unit) in Malaysia?
Provide a succinct answer. -2.14e+11. In the year 2004, what is the difference between the Imports (in Local Currency Unit) in Israel and Imports (in Local Currency Unit) in Oman?
Your answer should be compact. 2.33e+11. In the year 2004, what is the difference between the Imports (in Local Currency Unit) in Israel and Imports (in Local Currency Unit) in Russian Federation?
Give a very brief answer. -3.54e+12. In the year 2004, what is the difference between the Imports (in Local Currency Unit) in Malaysia and Imports (in Local Currency Unit) in Oman?
Provide a short and direct response. 4.47e+11. In the year 2004, what is the difference between the Imports (in Local Currency Unit) in Malaysia and Imports (in Local Currency Unit) in Russian Federation?
Offer a very short reply. -3.32e+12. In the year 2004, what is the difference between the Imports (in Local Currency Unit) of Oman and Imports (in Local Currency Unit) of Russian Federation?
Provide a succinct answer. -3.77e+12. In the year 2005, what is the difference between the Imports (in Local Currency Unit) of Israel and Imports (in Local Currency Unit) of Malaysia?
Keep it short and to the point. -2.33e+11. In the year 2005, what is the difference between the Imports (in Local Currency Unit) of Israel and Imports (in Local Currency Unit) of Oman?
Provide a succinct answer. 2.57e+11. In the year 2005, what is the difference between the Imports (in Local Currency Unit) in Israel and Imports (in Local Currency Unit) in Russian Federation?
Make the answer very short. -4.39e+12. In the year 2005, what is the difference between the Imports (in Local Currency Unit) in Malaysia and Imports (in Local Currency Unit) in Oman?
Your answer should be compact. 4.91e+11. In the year 2005, what is the difference between the Imports (in Local Currency Unit) of Malaysia and Imports (in Local Currency Unit) of Russian Federation?
Provide a succinct answer. -4.15e+12. In the year 2005, what is the difference between the Imports (in Local Currency Unit) of Oman and Imports (in Local Currency Unit) of Russian Federation?
Provide a short and direct response. -4.64e+12. In the year 2006, what is the difference between the Imports (in Local Currency Unit) in Israel and Imports (in Local Currency Unit) in Malaysia?
Offer a terse response. -2.62e+11. In the year 2006, what is the difference between the Imports (in Local Currency Unit) of Israel and Imports (in Local Currency Unit) of Oman?
Give a very brief answer. 2.73e+11. In the year 2006, what is the difference between the Imports (in Local Currency Unit) in Israel and Imports (in Local Currency Unit) in Russian Federation?
Give a very brief answer. -5.38e+12. In the year 2006, what is the difference between the Imports (in Local Currency Unit) in Malaysia and Imports (in Local Currency Unit) in Oman?
Make the answer very short. 5.35e+11. In the year 2006, what is the difference between the Imports (in Local Currency Unit) of Malaysia and Imports (in Local Currency Unit) of Russian Federation?
Your response must be concise. -5.11e+12. In the year 2006, what is the difference between the Imports (in Local Currency Unit) in Oman and Imports (in Local Currency Unit) in Russian Federation?
Provide a short and direct response. -5.65e+12. In the year 2007, what is the difference between the Imports (in Local Currency Unit) of Israel and Imports (in Local Currency Unit) of Malaysia?
Keep it short and to the point. -2.71e+11. In the year 2007, what is the difference between the Imports (in Local Currency Unit) in Israel and Imports (in Local Currency Unit) in Oman?
Your answer should be very brief. 2.96e+11. In the year 2007, what is the difference between the Imports (in Local Currency Unit) in Israel and Imports (in Local Currency Unit) in Russian Federation?
Make the answer very short. -6.86e+12. In the year 2007, what is the difference between the Imports (in Local Currency Unit) of Malaysia and Imports (in Local Currency Unit) of Oman?
Make the answer very short. 5.68e+11. In the year 2007, what is the difference between the Imports (in Local Currency Unit) in Malaysia and Imports (in Local Currency Unit) in Russian Federation?
Keep it short and to the point. -6.59e+12. In the year 2007, what is the difference between the Imports (in Local Currency Unit) in Oman and Imports (in Local Currency Unit) in Russian Federation?
Ensure brevity in your answer.  -7.16e+12. In the year 2008, what is the difference between the Imports (in Local Currency Unit) of Israel and Imports (in Local Currency Unit) of Malaysia?
Provide a succinct answer. -2.92e+11. In the year 2008, what is the difference between the Imports (in Local Currency Unit) of Israel and Imports (in Local Currency Unit) of Oman?
Give a very brief answer. 2.93e+11. In the year 2008, what is the difference between the Imports (in Local Currency Unit) of Israel and Imports (in Local Currency Unit) of Russian Federation?
Provide a short and direct response. -8.81e+12. In the year 2008, what is the difference between the Imports (in Local Currency Unit) in Malaysia and Imports (in Local Currency Unit) in Oman?
Provide a succinct answer. 5.85e+11. In the year 2008, what is the difference between the Imports (in Local Currency Unit) in Malaysia and Imports (in Local Currency Unit) in Russian Federation?
Provide a short and direct response. -8.52e+12. In the year 2008, what is the difference between the Imports (in Local Currency Unit) of Oman and Imports (in Local Currency Unit) of Russian Federation?
Make the answer very short. -9.10e+12. In the year 2009, what is the difference between the Imports (in Local Currency Unit) in Israel and Imports (in Local Currency Unit) in Malaysia?
Make the answer very short. -2.58e+11. In the year 2009, what is the difference between the Imports (in Local Currency Unit) in Israel and Imports (in Local Currency Unit) in Oman?
Make the answer very short. 2.43e+11. In the year 2009, what is the difference between the Imports (in Local Currency Unit) of Israel and Imports (in Local Currency Unit) of Russian Federation?
Your answer should be very brief. -7.71e+12. In the year 2009, what is the difference between the Imports (in Local Currency Unit) in Malaysia and Imports (in Local Currency Unit) in Oman?
Keep it short and to the point. 5.01e+11. In the year 2009, what is the difference between the Imports (in Local Currency Unit) in Malaysia and Imports (in Local Currency Unit) in Russian Federation?
Your response must be concise. -7.45e+12. In the year 2009, what is the difference between the Imports (in Local Currency Unit) in Oman and Imports (in Local Currency Unit) in Russian Federation?
Keep it short and to the point. -7.95e+12. What is the ratio of the Imports (in Local Currency Unit) of Israel in 2003 to that in 2004?
Ensure brevity in your answer.  0.86. What is the ratio of the Imports (in Local Currency Unit) of Malaysia in 2003 to that in 2004?
Make the answer very short. 0.81. What is the ratio of the Imports (in Local Currency Unit) in Oman in 2003 to that in 2004?
Ensure brevity in your answer.  0.74. What is the ratio of the Imports (in Local Currency Unit) in Russian Federation in 2003 to that in 2004?
Your answer should be compact. 0.84. What is the ratio of the Imports (in Local Currency Unit) in Israel in 2003 to that in 2005?
Keep it short and to the point. 0.78. What is the ratio of the Imports (in Local Currency Unit) in Malaysia in 2003 to that in 2005?
Your answer should be compact. 0.74. What is the ratio of the Imports (in Local Currency Unit) in Oman in 2003 to that in 2005?
Give a very brief answer. 0.73. What is the ratio of the Imports (in Local Currency Unit) of Russian Federation in 2003 to that in 2005?
Give a very brief answer. 0.68. What is the ratio of the Imports (in Local Currency Unit) in Israel in 2003 to that in 2006?
Provide a short and direct response. 0.73. What is the ratio of the Imports (in Local Currency Unit) in Malaysia in 2003 to that in 2006?
Offer a terse response. 0.68. What is the ratio of the Imports (in Local Currency Unit) of Oman in 2003 to that in 2006?
Ensure brevity in your answer.  0.6. What is the ratio of the Imports (in Local Currency Unit) of Russian Federation in 2003 to that in 2006?
Give a very brief answer. 0.56. What is the ratio of the Imports (in Local Currency Unit) of Israel in 2003 to that in 2007?
Offer a terse response. 0.67. What is the ratio of the Imports (in Local Currency Unit) of Malaysia in 2003 to that in 2007?
Your response must be concise. 0.64. What is the ratio of the Imports (in Local Currency Unit) of Oman in 2003 to that in 2007?
Keep it short and to the point. 0.42. What is the ratio of the Imports (in Local Currency Unit) of Russian Federation in 2003 to that in 2007?
Your answer should be compact. 0.44. What is the ratio of the Imports (in Local Currency Unit) of Israel in 2003 to that in 2008?
Your response must be concise. 0.68. What is the ratio of the Imports (in Local Currency Unit) of Malaysia in 2003 to that in 2008?
Provide a succinct answer. 0.61. What is the ratio of the Imports (in Local Currency Unit) in Oman in 2003 to that in 2008?
Make the answer very short. 0.31. What is the ratio of the Imports (in Local Currency Unit) of Russian Federation in 2003 to that in 2008?
Give a very brief answer. 0.35. What is the ratio of the Imports (in Local Currency Unit) of Israel in 2003 to that in 2009?
Keep it short and to the point. 0.82. What is the ratio of the Imports (in Local Currency Unit) of Malaysia in 2003 to that in 2009?
Your answer should be compact. 0.72. What is the ratio of the Imports (in Local Currency Unit) in Oman in 2003 to that in 2009?
Your answer should be compact. 0.42. What is the ratio of the Imports (in Local Currency Unit) of Russian Federation in 2003 to that in 2009?
Provide a succinct answer. 0.4. What is the ratio of the Imports (in Local Currency Unit) of Israel in 2004 to that in 2005?
Your answer should be compact. 0.91. What is the ratio of the Imports (in Local Currency Unit) in Malaysia in 2004 to that in 2005?
Provide a short and direct response. 0.91. What is the ratio of the Imports (in Local Currency Unit) of Oman in 2004 to that in 2005?
Provide a short and direct response. 1. What is the ratio of the Imports (in Local Currency Unit) of Russian Federation in 2004 to that in 2005?
Your answer should be compact. 0.81. What is the ratio of the Imports (in Local Currency Unit) in Israel in 2004 to that in 2006?
Ensure brevity in your answer.  0.85. What is the ratio of the Imports (in Local Currency Unit) in Malaysia in 2004 to that in 2006?
Your answer should be very brief. 0.83. What is the ratio of the Imports (in Local Currency Unit) in Oman in 2004 to that in 2006?
Your response must be concise. 0.82. What is the ratio of the Imports (in Local Currency Unit) in Russian Federation in 2004 to that in 2006?
Keep it short and to the point. 0.67. What is the ratio of the Imports (in Local Currency Unit) of Israel in 2004 to that in 2007?
Ensure brevity in your answer.  0.78. What is the ratio of the Imports (in Local Currency Unit) of Malaysia in 2004 to that in 2007?
Your answer should be very brief. 0.78. What is the ratio of the Imports (in Local Currency Unit) in Oman in 2004 to that in 2007?
Give a very brief answer. 0.57. What is the ratio of the Imports (in Local Currency Unit) in Russian Federation in 2004 to that in 2007?
Offer a terse response. 0.53. What is the ratio of the Imports (in Local Currency Unit) in Israel in 2004 to that in 2008?
Your answer should be very brief. 0.78. What is the ratio of the Imports (in Local Currency Unit) in Malaysia in 2004 to that in 2008?
Provide a short and direct response. 0.76. What is the ratio of the Imports (in Local Currency Unit) in Oman in 2004 to that in 2008?
Make the answer very short. 0.43. What is the ratio of the Imports (in Local Currency Unit) in Russian Federation in 2004 to that in 2008?
Ensure brevity in your answer.  0.41. What is the ratio of the Imports (in Local Currency Unit) of Israel in 2004 to that in 2009?
Give a very brief answer. 0.95. What is the ratio of the Imports (in Local Currency Unit) of Malaysia in 2004 to that in 2009?
Your answer should be compact. 0.89. What is the ratio of the Imports (in Local Currency Unit) of Oman in 2004 to that in 2009?
Give a very brief answer. 0.57. What is the ratio of the Imports (in Local Currency Unit) in Russian Federation in 2004 to that in 2009?
Make the answer very short. 0.47. What is the ratio of the Imports (in Local Currency Unit) of Israel in 2005 to that in 2006?
Offer a very short reply. 0.94. What is the ratio of the Imports (in Local Currency Unit) in Malaysia in 2005 to that in 2006?
Ensure brevity in your answer.  0.92. What is the ratio of the Imports (in Local Currency Unit) in Oman in 2005 to that in 2006?
Give a very brief answer. 0.82. What is the ratio of the Imports (in Local Currency Unit) of Russian Federation in 2005 to that in 2006?
Provide a short and direct response. 0.82. What is the ratio of the Imports (in Local Currency Unit) in Israel in 2005 to that in 2007?
Offer a very short reply. 0.86. What is the ratio of the Imports (in Local Currency Unit) of Malaysia in 2005 to that in 2007?
Offer a terse response. 0.86. What is the ratio of the Imports (in Local Currency Unit) in Oman in 2005 to that in 2007?
Offer a very short reply. 0.57. What is the ratio of the Imports (in Local Currency Unit) in Russian Federation in 2005 to that in 2007?
Ensure brevity in your answer.  0.65. What is the ratio of the Imports (in Local Currency Unit) of Israel in 2005 to that in 2008?
Make the answer very short. 0.86. What is the ratio of the Imports (in Local Currency Unit) of Malaysia in 2005 to that in 2008?
Your response must be concise. 0.83. What is the ratio of the Imports (in Local Currency Unit) in Oman in 2005 to that in 2008?
Your response must be concise. 0.43. What is the ratio of the Imports (in Local Currency Unit) in Russian Federation in 2005 to that in 2008?
Offer a terse response. 0.51. What is the ratio of the Imports (in Local Currency Unit) in Israel in 2005 to that in 2009?
Keep it short and to the point. 1.05. What is the ratio of the Imports (in Local Currency Unit) in Malaysia in 2005 to that in 2009?
Ensure brevity in your answer.  0.97. What is the ratio of the Imports (in Local Currency Unit) of Oman in 2005 to that in 2009?
Your response must be concise. 0.58. What is the ratio of the Imports (in Local Currency Unit) of Russian Federation in 2005 to that in 2009?
Keep it short and to the point. 0.58. What is the ratio of the Imports (in Local Currency Unit) in Israel in 2006 to that in 2007?
Your answer should be very brief. 0.92. What is the ratio of the Imports (in Local Currency Unit) of Malaysia in 2006 to that in 2007?
Offer a terse response. 0.94. What is the ratio of the Imports (in Local Currency Unit) of Oman in 2006 to that in 2007?
Provide a short and direct response. 0.7. What is the ratio of the Imports (in Local Currency Unit) of Russian Federation in 2006 to that in 2007?
Provide a succinct answer. 0.79. What is the ratio of the Imports (in Local Currency Unit) in Israel in 2006 to that in 2008?
Your answer should be very brief. 0.92. What is the ratio of the Imports (in Local Currency Unit) in Malaysia in 2006 to that in 2008?
Offer a very short reply. 0.91. What is the ratio of the Imports (in Local Currency Unit) of Oman in 2006 to that in 2008?
Keep it short and to the point. 0.52. What is the ratio of the Imports (in Local Currency Unit) in Russian Federation in 2006 to that in 2008?
Make the answer very short. 0.62. What is the ratio of the Imports (in Local Currency Unit) of Israel in 2006 to that in 2009?
Provide a short and direct response. 1.12. What is the ratio of the Imports (in Local Currency Unit) in Malaysia in 2006 to that in 2009?
Offer a terse response. 1.06. What is the ratio of the Imports (in Local Currency Unit) in Oman in 2006 to that in 2009?
Offer a very short reply. 0.7. What is the ratio of the Imports (in Local Currency Unit) in Russian Federation in 2006 to that in 2009?
Your answer should be very brief. 0.71. What is the ratio of the Imports (in Local Currency Unit) in Israel in 2007 to that in 2008?
Provide a short and direct response. 1. What is the ratio of the Imports (in Local Currency Unit) in Malaysia in 2007 to that in 2008?
Provide a short and direct response. 0.97. What is the ratio of the Imports (in Local Currency Unit) in Oman in 2007 to that in 2008?
Your answer should be very brief. 0.74. What is the ratio of the Imports (in Local Currency Unit) in Russian Federation in 2007 to that in 2008?
Provide a succinct answer. 0.79. What is the ratio of the Imports (in Local Currency Unit) of Israel in 2007 to that in 2009?
Provide a short and direct response. 1.22. What is the ratio of the Imports (in Local Currency Unit) of Malaysia in 2007 to that in 2009?
Provide a short and direct response. 1.13. What is the ratio of the Imports (in Local Currency Unit) in Russian Federation in 2007 to that in 2009?
Offer a terse response. 0.9. What is the ratio of the Imports (in Local Currency Unit) of Israel in 2008 to that in 2009?
Your answer should be compact. 1.21. What is the ratio of the Imports (in Local Currency Unit) of Malaysia in 2008 to that in 2009?
Your response must be concise. 1.17. What is the ratio of the Imports (in Local Currency Unit) of Oman in 2008 to that in 2009?
Ensure brevity in your answer.  1.35. What is the ratio of the Imports (in Local Currency Unit) of Russian Federation in 2008 to that in 2009?
Keep it short and to the point. 1.15. What is the difference between the highest and the second highest Imports (in Local Currency Unit) of Israel?
Your response must be concise. 1.01e+09. What is the difference between the highest and the second highest Imports (in Local Currency Unit) in Malaysia?
Ensure brevity in your answer.  2.00e+1. What is the difference between the highest and the second highest Imports (in Local Currency Unit) in Oman?
Ensure brevity in your answer.  2.24e+09. What is the difference between the highest and the second highest Imports (in Local Currency Unit) in Russian Federation?
Your response must be concise. 1.16e+12. What is the difference between the highest and the lowest Imports (in Local Currency Unit) in Israel?
Your answer should be compact. 9.89e+1. What is the difference between the highest and the lowest Imports (in Local Currency Unit) in Malaysia?
Offer a terse response. 2.29e+11. What is the difference between the highest and the lowest Imports (in Local Currency Unit) of Oman?
Your answer should be compact. 5.98e+09. What is the difference between the highest and the lowest Imports (in Local Currency Unit) in Russian Federation?
Offer a terse response. 5.96e+12. 